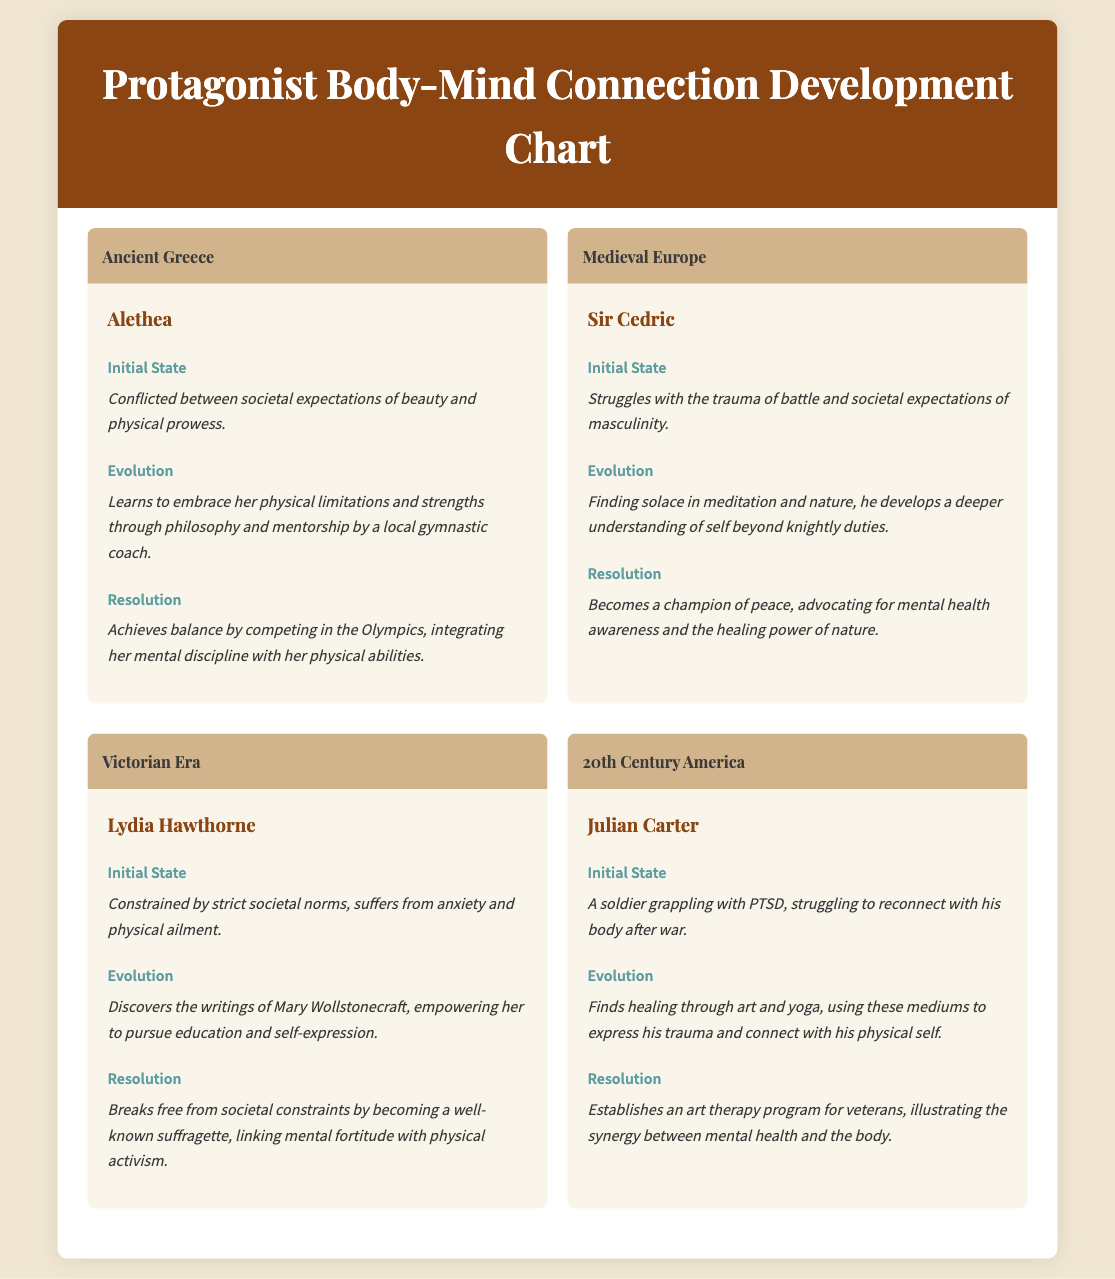What is the name of the protagonist from Ancient Greece? The document presents a character from Ancient Greece named Alethea.
Answer: Alethea What traumatic experience does Sir Cedric struggle with? According to the document, Sir Cedric struggles with the trauma of battle.
Answer: Trauma of battle Which historical era is Lydia Hawthorne associated with? The document identifies Lydia Hawthorne as being from the Victorian Era.
Answer: Victorian Era What helps Julian Carter reconnect with his body after war? The document states that Julian finds healing through art and yoga.
Answer: Art and yoga What is the role of Alethea in the Olympics? Alethea achieves balance by competing, which showcases her integration of mental discipline and physical abilities.
Answer: Competing in the Olympics Which philosopher influences Lydia Hawthorne's evolution? The document mentions that Lydia is influenced by the writings of Mary Wollstonecraft.
Answer: Mary Wollstonecraft What is a common theme across all protagonists? The document highlights the theme of integrating mental health with physical experiences.
Answer: Integrating mental health with physical experiences What is the final resolution for Sir Cedric? Sir Cedric becomes a champion of peace, advocating for mental health awareness.
Answer: Champion of peace How does Julian Carter illustrate the synergy between mental health and the body? Julian establishes an art therapy program for veterans to illustrate this synergy.
Answer: Art therapy program for veterans 